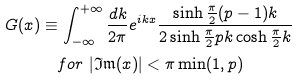Convert formula to latex. <formula><loc_0><loc_0><loc_500><loc_500>G ( x ) & \equiv \int _ { - \infty } ^ { + \infty } \frac { d k } { 2 \pi } e ^ { i k x } \frac { \sinh \frac { \pi } { 2 } ( p - 1 ) k } { 2 \sinh \frac { \pi } { 2 } p k \cosh \frac { \pi } { 2 } k } \quad \\ & \quad f o r \, \left | \mathfrak { I m } ( x ) \right | < \pi \min ( 1 , p )</formula> 